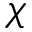Convert formula to latex. <formula><loc_0><loc_0><loc_500><loc_500>\chi</formula> 